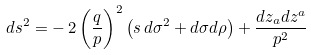Convert formula to latex. <formula><loc_0><loc_0><loc_500><loc_500>d s ^ { 2 } = - \, 2 \left ( { \frac { q } { p } } \right ) ^ { 2 } \left ( s \, d \sigma ^ { 2 } + d \sigma d \rho \right ) + { \frac { d z _ { a } d z ^ { a } } { p ^ { 2 } } }</formula> 